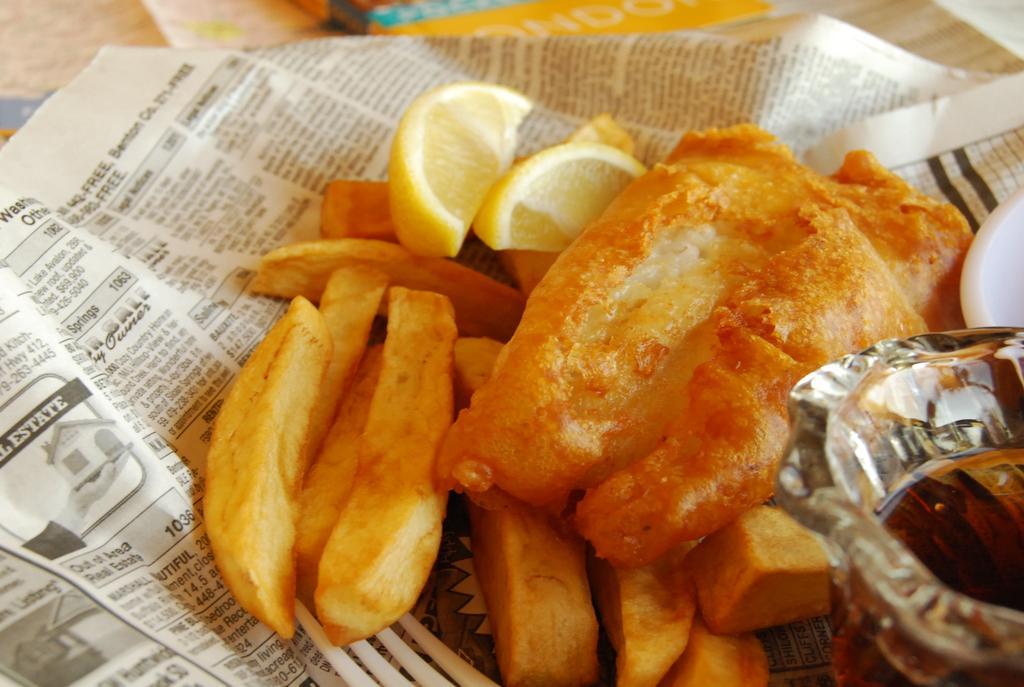<image>
Provide a brief description of the given image. Food is served on newspaper that has an image of a home printed on it with the word Estate written above it. 